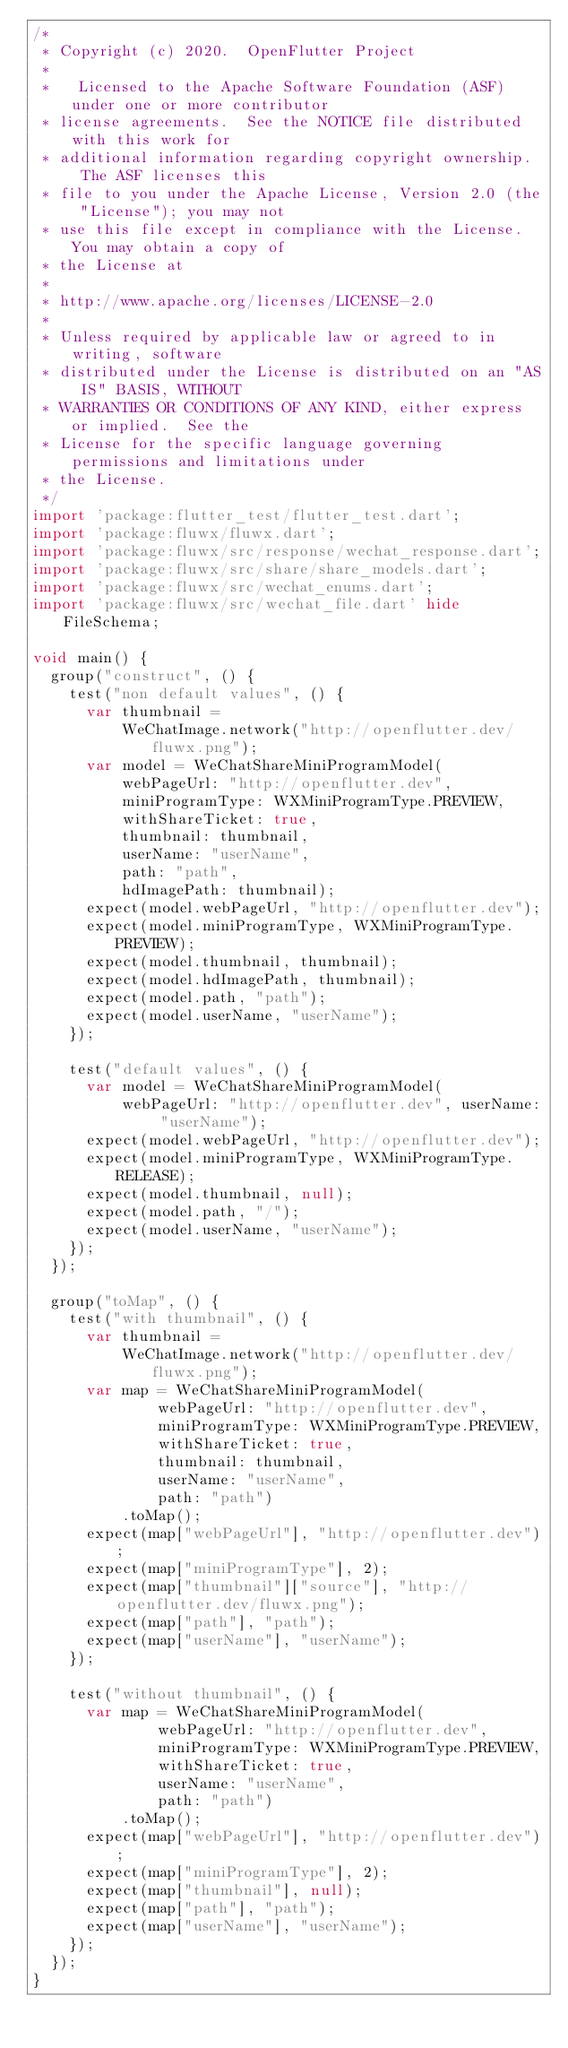<code> <loc_0><loc_0><loc_500><loc_500><_Dart_>/*
 * Copyright (c) 2020.  OpenFlutter Project
 *
 *   Licensed to the Apache Software Foundation (ASF) under one or more contributor
 * license agreements.  See the NOTICE file distributed with this work for
 * additional information regarding copyright ownership.  The ASF licenses this
 * file to you under the Apache License, Version 2.0 (the "License"); you may not
 * use this file except in compliance with the License.  You may obtain a copy of
 * the License at
 *
 * http://www.apache.org/licenses/LICENSE-2.0
 *
 * Unless required by applicable law or agreed to in writing, software
 * distributed under the License is distributed on an "AS IS" BASIS, WITHOUT
 * WARRANTIES OR CONDITIONS OF ANY KIND, either express or implied.  See the
 * License for the specific language governing permissions and limitations under
 * the License.
 */
import 'package:flutter_test/flutter_test.dart';
import 'package:fluwx/fluwx.dart';
import 'package:fluwx/src/response/wechat_response.dart';
import 'package:fluwx/src/share/share_models.dart';
import 'package:fluwx/src/wechat_enums.dart';
import 'package:fluwx/src/wechat_file.dart' hide FileSchema;

void main() {
  group("construct", () {
    test("non default values", () {
      var thumbnail =
          WeChatImage.network("http://openflutter.dev/fluwx.png");
      var model = WeChatShareMiniProgramModel(
          webPageUrl: "http://openflutter.dev",
          miniProgramType: WXMiniProgramType.PREVIEW,
          withShareTicket: true,
          thumbnail: thumbnail,
          userName: "userName",
          path: "path",
          hdImagePath: thumbnail);
      expect(model.webPageUrl, "http://openflutter.dev");
      expect(model.miniProgramType, WXMiniProgramType.PREVIEW);
      expect(model.thumbnail, thumbnail);
      expect(model.hdImagePath, thumbnail);
      expect(model.path, "path");
      expect(model.userName, "userName");
    });

    test("default values", () {
      var model = WeChatShareMiniProgramModel(
          webPageUrl: "http://openflutter.dev", userName: "userName");
      expect(model.webPageUrl, "http://openflutter.dev");
      expect(model.miniProgramType, WXMiniProgramType.RELEASE);
      expect(model.thumbnail, null);
      expect(model.path, "/");
      expect(model.userName, "userName");
    });
  });

  group("toMap", () {
    test("with thumbnail", () {
      var thumbnail =
          WeChatImage.network("http://openflutter.dev/fluwx.png");
      var map = WeChatShareMiniProgramModel(
              webPageUrl: "http://openflutter.dev",
              miniProgramType: WXMiniProgramType.PREVIEW,
              withShareTicket: true,
              thumbnail: thumbnail,
              userName: "userName",
              path: "path")
          .toMap();
      expect(map["webPageUrl"], "http://openflutter.dev");
      expect(map["miniProgramType"], 2);
      expect(map["thumbnail"]["source"], "http://openflutter.dev/fluwx.png");
      expect(map["path"], "path");
      expect(map["userName"], "userName");
    });

    test("without thumbnail", () {
      var map = WeChatShareMiniProgramModel(
              webPageUrl: "http://openflutter.dev",
              miniProgramType: WXMiniProgramType.PREVIEW,
              withShareTicket: true,
              userName: "userName",
              path: "path")
          .toMap();
      expect(map["webPageUrl"], "http://openflutter.dev");
      expect(map["miniProgramType"], 2);
      expect(map["thumbnail"], null);
      expect(map["path"], "path");
      expect(map["userName"], "userName");
    });
  });
}
</code> 